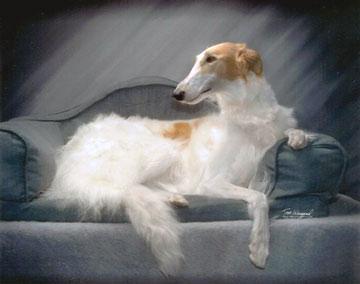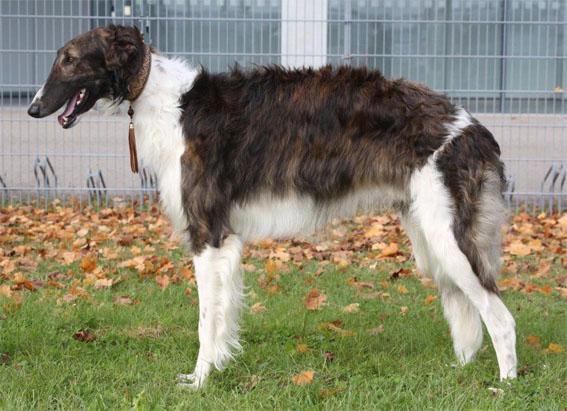The first image is the image on the left, the second image is the image on the right. For the images shown, is this caption "At least one dog has a dark face, and the dogs in the left and right images have the same face position, with eyes gazing the same direction." true? Answer yes or no. Yes. The first image is the image on the left, the second image is the image on the right. Given the left and right images, does the statement "In both images only the head of the dog can be seen and not the rest of the dogs body." hold true? Answer yes or no. No. 